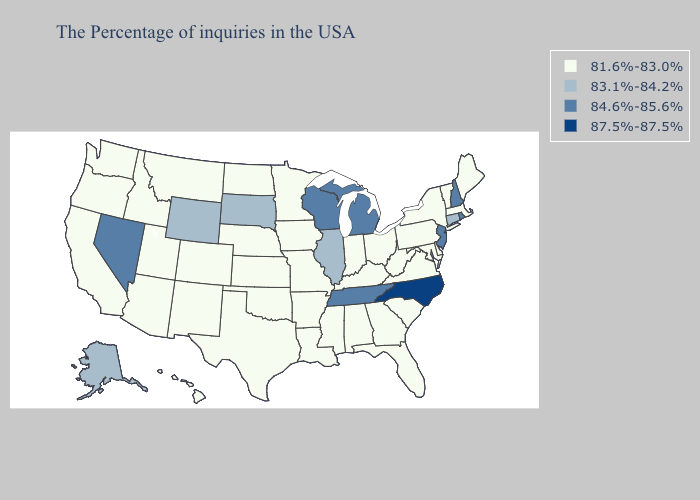Does Washington have the same value as Tennessee?
Write a very short answer. No. Does Maine have the highest value in the Northeast?
Give a very brief answer. No. What is the value of Tennessee?
Short answer required. 84.6%-85.6%. What is the value of Missouri?
Concise answer only. 81.6%-83.0%. Name the states that have a value in the range 87.5%-87.5%?
Answer briefly. North Carolina. Does the map have missing data?
Answer briefly. No. How many symbols are there in the legend?
Write a very short answer. 4. Among the states that border Delaware , which have the highest value?
Short answer required. New Jersey. Name the states that have a value in the range 81.6%-83.0%?
Give a very brief answer. Maine, Massachusetts, Vermont, New York, Delaware, Maryland, Pennsylvania, Virginia, South Carolina, West Virginia, Ohio, Florida, Georgia, Kentucky, Indiana, Alabama, Mississippi, Louisiana, Missouri, Arkansas, Minnesota, Iowa, Kansas, Nebraska, Oklahoma, Texas, North Dakota, Colorado, New Mexico, Utah, Montana, Arizona, Idaho, California, Washington, Oregon, Hawaii. What is the highest value in the South ?
Be succinct. 87.5%-87.5%. What is the lowest value in the South?
Quick response, please. 81.6%-83.0%. What is the value of Kansas?
Write a very short answer. 81.6%-83.0%. Among the states that border Colorado , which have the highest value?
Quick response, please. Wyoming. Name the states that have a value in the range 81.6%-83.0%?
Keep it brief. Maine, Massachusetts, Vermont, New York, Delaware, Maryland, Pennsylvania, Virginia, South Carolina, West Virginia, Ohio, Florida, Georgia, Kentucky, Indiana, Alabama, Mississippi, Louisiana, Missouri, Arkansas, Minnesota, Iowa, Kansas, Nebraska, Oklahoma, Texas, North Dakota, Colorado, New Mexico, Utah, Montana, Arizona, Idaho, California, Washington, Oregon, Hawaii. What is the value of Colorado?
Give a very brief answer. 81.6%-83.0%. 